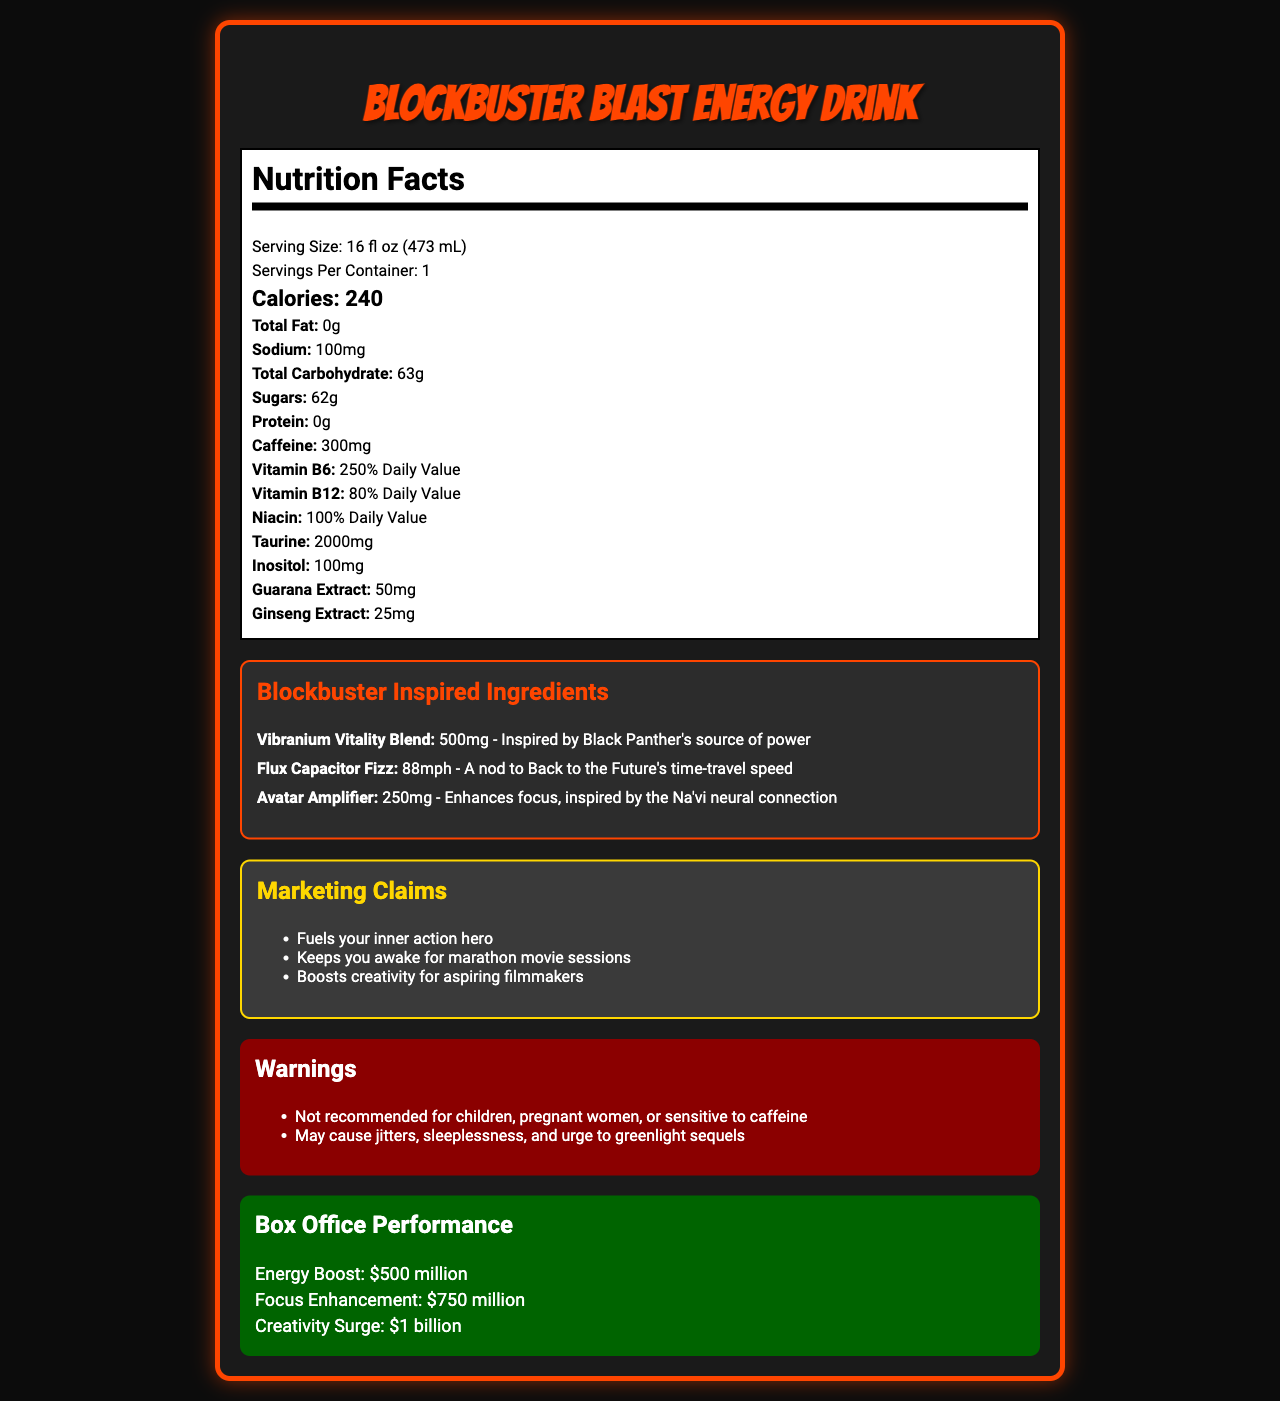what is the serving size for BlockBuster Blast Energy Drink? The document clearly states that the serving size for BlockBuster Blast Energy Drink is 16 fl oz (473 mL).
Answer: 16 fl oz (473 mL) how many calories are there per serving? The Nutrition Facts section lists the calorie count as 240 per serving.
Answer: 240 how much caffeine is in the BlockBuster Blast Energy Drink? The document lists the caffeine content as 300mg under the Nutrition Facts.
Answer: 300mg which vitamins are listed, and what are their daily values? The vitamins and their respective daily values are clearly listed under the Nutrition Facts section.
Answer: Vitamin B6 (250% Daily Value), Vitamin B12 (80% Daily Value), Niacin (100% Daily Value) what is the amount of sugar in the energy drink? The document specifies that the energy drink contains 62 grams of sugar per serving.
Answer: 62g what unique ingredient is inspired by Black Panther's source of power? The document mentions the "Vibranium Vitality Blend" as being inspired by Black Panther's source of power.
Answer: Vibranium Vitality Blend which of the following is a warning given in the document? A. Contains dairy B. Not recommended for children C. May contain nuts D. Gluten-free The document lists a warning specifically mentioning that it is not recommended for children.
Answer: B. Not recommended for children which marketing claim suggests the energy drink can help with long movie sessions? A. Boosts creativity for aspiring filmmakers B. Fuels your inner action hero C. Keeps you awake for marathon movie sessions D. Enhances focus, inspired by the Na'vi neural connection The third marketing claim clearly states that the drink "Keeps you awake for marathon movie sessions."
Answer: C. Keeps you awake for marathon movie sessions does the BlockBuster Blast Energy Drink contain protein? The document lists the protein content as 0 grams.
Answer: No how is the "Flux Capacitor Fizz" ingredient described? According to the document, the "Flux Capacitor Fizz" is a nod to Back to the Future's time-travel speed.
Answer: A nod to Back to the Future's time-travel speed summarize the main features of the BlockBuster Blast Energy Drink. The energy drink targets fans of blockbuster movies, highlighting high energy content and themed ingredients inspired by popular films, along with a playful 'box office' success metric.
Answer: The BlockBuster Blast Energy Drink is a high-caffeine energy drink inspired by blockbuster movies. It contains 240 calories per serving, 300mg of caffeine, and high amounts of sugar. Unique ingredients include Vibranium Vitality Blend, Flux Capacitor Fizz, and Avatar Amplifier. It offers several marketing claims, such as fueling your inner action hero and boosting creativity. The product includes warnings for specific populations and a theatrical 'box office performance' section indicating significant boosts in energy, focus, and creativity. how much taurine is in the drink, and what benefit might it provide? The document states that the energy drink contains 2000mg of taurine. Taurine is often added to energy drinks for its potential to improve athletic performance and reduce muscle fatigue.
Answer: 2000mg what are the measured content quantities for guarana extract and ginseng extract? The nutrition label states that the drink contains 50mg of guarana extract and 25mg of ginseng extract.
Answer: 50mg and 25mg, respectively how does the "Avatar Amplifier" ingredient claim to enhance performance? The "Avatar Amplifier" is aimed at enhancing focus, inspired by the neural connection of the Na'vi in Avatar.
Answer: Enhances focus, inspired by the Na'vi neural connection what is the sodium content per serving? The document lists the sodium content as 100mg per serving.
Answer: 100mg how much inositol is in the drink? The amount of inositol present in the drink is stated as 100mg in the nutrition facts.
Answer: 100mg can the exact impact on box office performance be determined from the document? The 'box office performance' figures given for energy boost, focus enhancement, and creativity surge are playful and not actual monetary values.
Answer: No 